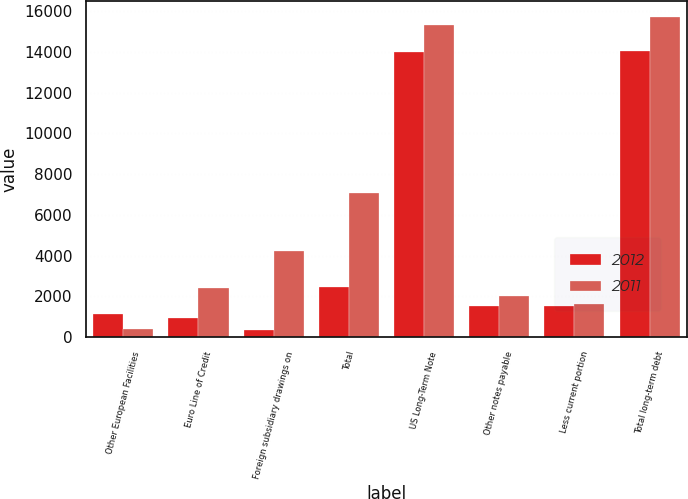Convert chart to OTSL. <chart><loc_0><loc_0><loc_500><loc_500><stacked_bar_chart><ecel><fcel>Other European Facilities<fcel>Euro Line of Credit<fcel>Foreign subsidiary drawings on<fcel>Total<fcel>US Long-Term Note<fcel>Other notes payable<fcel>Less current portion<fcel>Total long-term debt<nl><fcel>2012<fcel>1135<fcel>956<fcel>351<fcel>2442<fcel>14000<fcel>1519<fcel>1505<fcel>14014<nl><fcel>2011<fcel>393<fcel>2421<fcel>4243<fcel>7057<fcel>15333<fcel>2006<fcel>1613<fcel>15726<nl></chart> 